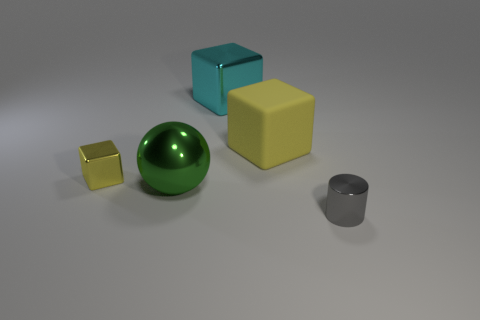Is there a tiny metal cylinder that is in front of the metal object that is on the right side of the large rubber object?
Give a very brief answer. No. How many shiny blocks are there?
Provide a succinct answer. 2. There is a sphere; is it the same color as the tiny thing behind the metal cylinder?
Your answer should be very brief. No. Are there more big cyan blocks than yellow cubes?
Provide a succinct answer. No. Is there any other thing that has the same color as the cylinder?
Offer a terse response. No. How many other things are there of the same size as the gray metallic cylinder?
Keep it short and to the point. 1. There is a small object in front of the object to the left of the big metallic thing that is left of the big cyan metal thing; what is its material?
Your response must be concise. Metal. Does the cyan object have the same material as the tiny thing that is on the left side of the cylinder?
Provide a short and direct response. Yes. Are there fewer big metal objects to the right of the big metallic ball than cyan things that are left of the cyan shiny cube?
Ensure brevity in your answer.  No. How many large cyan things have the same material as the gray cylinder?
Provide a short and direct response. 1. 